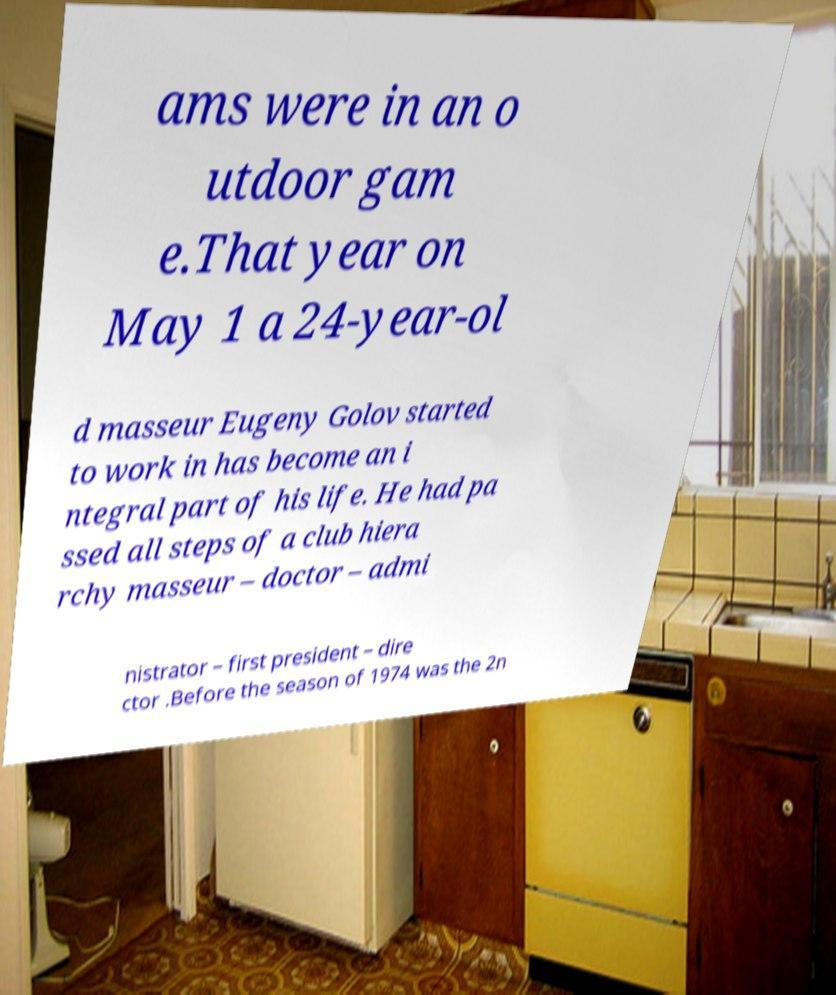What messages or text are displayed in this image? I need them in a readable, typed format. ams were in an o utdoor gam e.That year on May 1 a 24-year-ol d masseur Eugeny Golov started to work in has become an i ntegral part of his life. He had pa ssed all steps of a club hiera rchy masseur – doctor – admi nistrator – first president – dire ctor .Before the season of 1974 was the 2n 